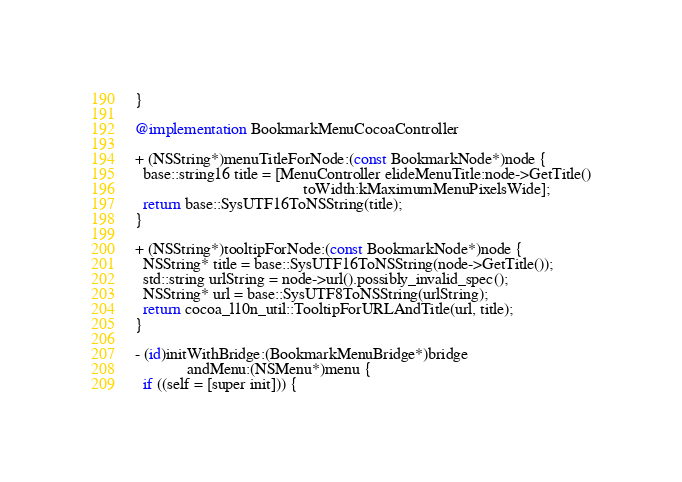<code> <loc_0><loc_0><loc_500><loc_500><_ObjectiveC_>}

@implementation BookmarkMenuCocoaController

+ (NSString*)menuTitleForNode:(const BookmarkNode*)node {
  base::string16 title = [MenuController elideMenuTitle:node->GetTitle()
                                          toWidth:kMaximumMenuPixelsWide];
  return base::SysUTF16ToNSString(title);
}

+ (NSString*)tooltipForNode:(const BookmarkNode*)node {
  NSString* title = base::SysUTF16ToNSString(node->GetTitle());
  std::string urlString = node->url().possibly_invalid_spec();
  NSString* url = base::SysUTF8ToNSString(urlString);
  return cocoa_l10n_util::TooltipForURLAndTitle(url, title);
}

- (id)initWithBridge:(BookmarkMenuBridge*)bridge
             andMenu:(NSMenu*)menu {
  if ((self = [super init])) {</code> 